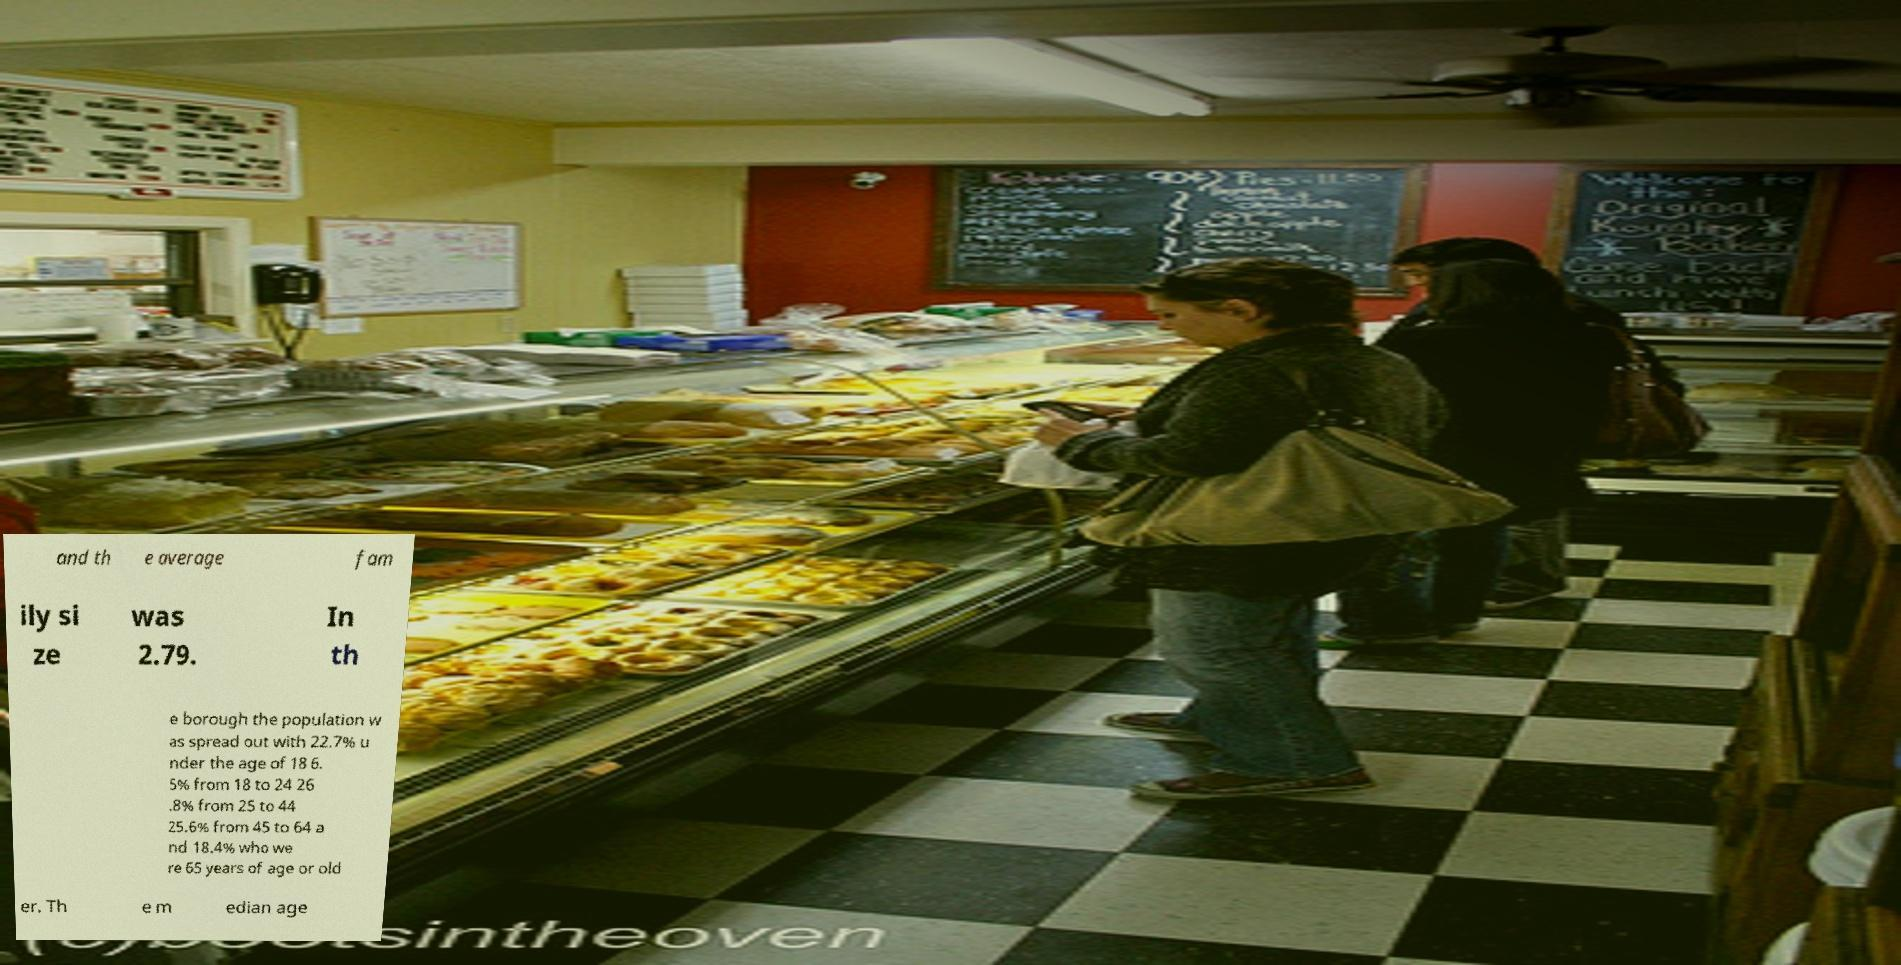What messages or text are displayed in this image? I need them in a readable, typed format. and th e average fam ily si ze was 2.79. In th e borough the population w as spread out with 22.7% u nder the age of 18 6. 5% from 18 to 24 26 .8% from 25 to 44 25.6% from 45 to 64 a nd 18.4% who we re 65 years of age or old er. Th e m edian age 